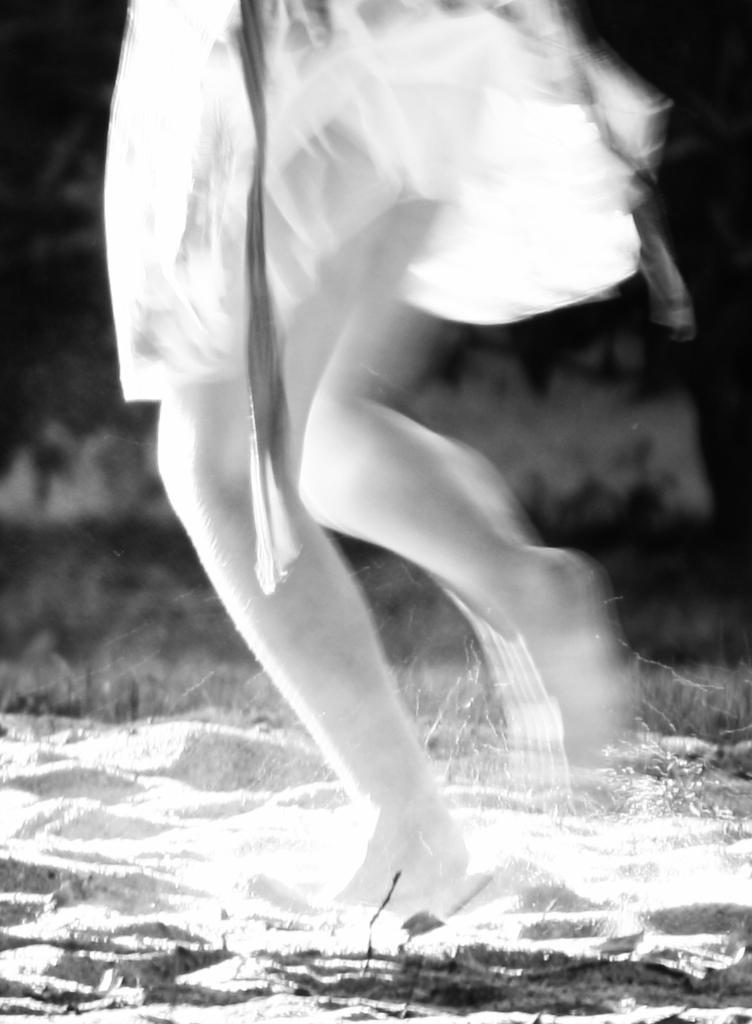What is the main subject of the image? The main subject of the image is a woman. What is the woman doing in the image? The woman is running in the image. Where is the woman located in the image? The woman is in the center of the image. What type of terrain is visible at the bottom of the image? There is sand visible at the bottom of the image. What type of railway can be seen in the image? There is no railway present in the image. What magical power does the woman possess in the image? There is no indication of any magical powers in the image; the woman is simply running. 